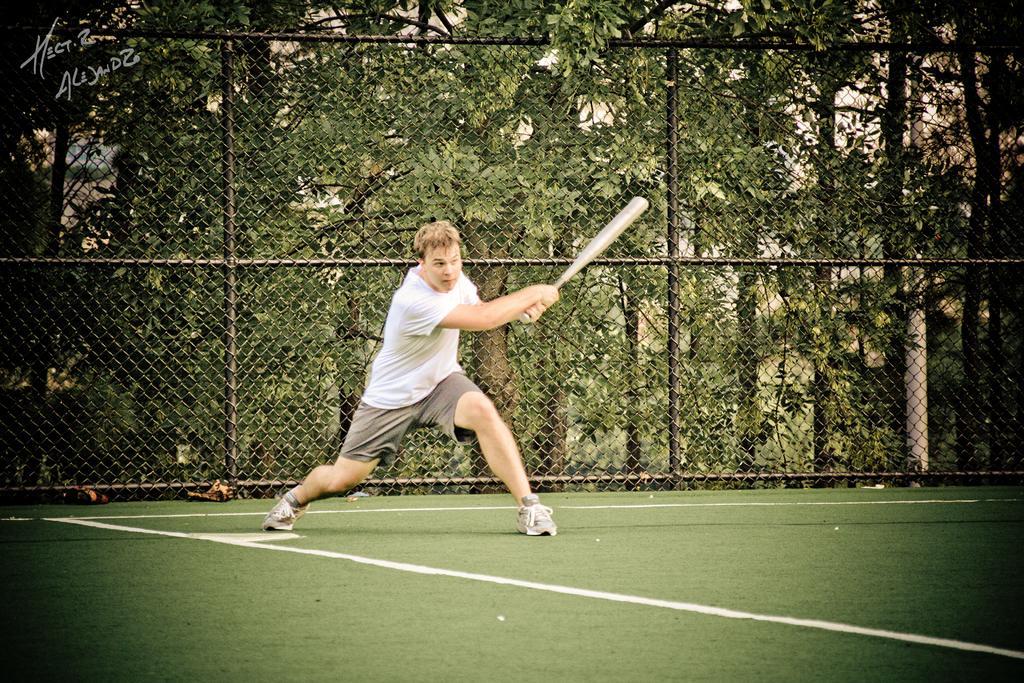Could you give a brief overview of what you see in this image? In this image we can see a man holding the bat and standing on the playground. We can also see the black color fence and behind the fence we can see the trees and also a pole. In the top left corner we can see the text. 